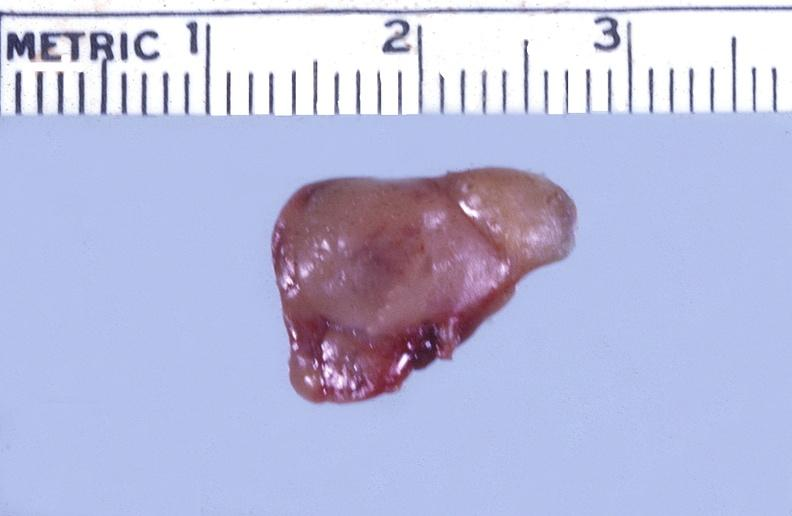does this image show parathyroid, functional adenoma?
Answer the question using a single word or phrase. Yes 